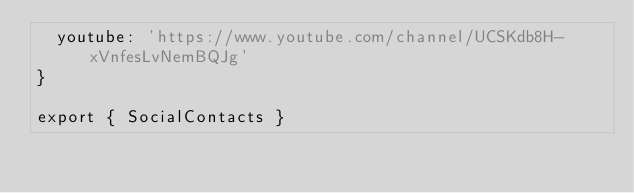Convert code to text. <code><loc_0><loc_0><loc_500><loc_500><_TypeScript_>  youtube: 'https://www.youtube.com/channel/UCSKdb8H-xVnfesLvNemBQJg'
}

export { SocialContacts }
</code> 